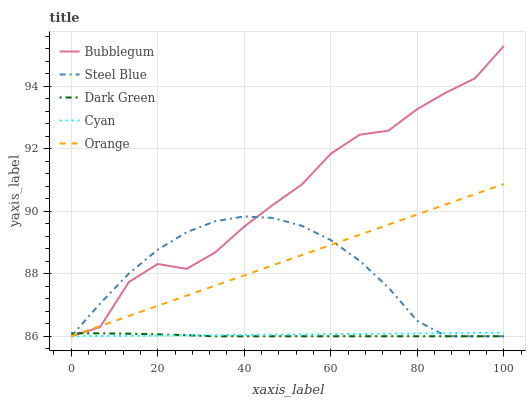Does Dark Green have the minimum area under the curve?
Answer yes or no. Yes. Does Bubblegum have the maximum area under the curve?
Answer yes or no. Yes. Does Cyan have the minimum area under the curve?
Answer yes or no. No. Does Cyan have the maximum area under the curve?
Answer yes or no. No. Is Cyan the smoothest?
Answer yes or no. Yes. Is Bubblegum the roughest?
Answer yes or no. Yes. Is Steel Blue the smoothest?
Answer yes or no. No. Is Steel Blue the roughest?
Answer yes or no. No. Does Orange have the lowest value?
Answer yes or no. Yes. Does Bubblegum have the highest value?
Answer yes or no. Yes. Does Cyan have the highest value?
Answer yes or no. No. Does Cyan intersect Orange?
Answer yes or no. Yes. Is Cyan less than Orange?
Answer yes or no. No. Is Cyan greater than Orange?
Answer yes or no. No. 